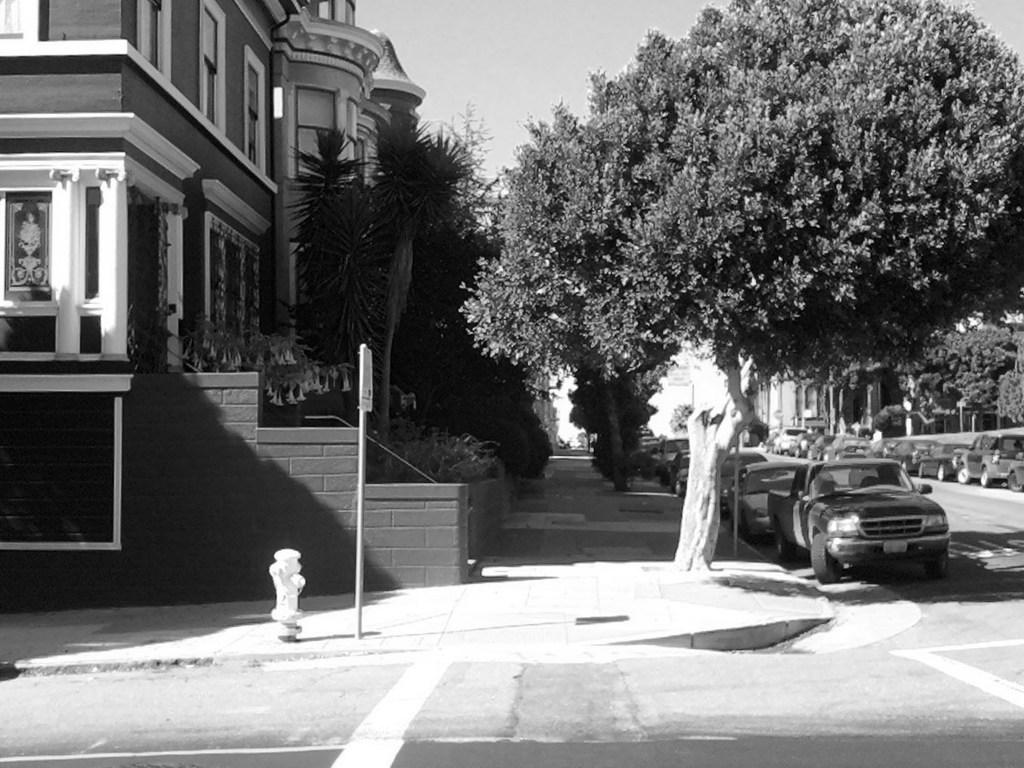What type of structures can be seen in the image? There are buildings in the image. What natural elements are visible in the image? There are trees visible in the image. What mode of transportation can be seen parked in the image? Cars are parked on the roads in the image. What color is the silver moon in the image? There is no moon visible in the image, and therefore no silver moon can be observed. 